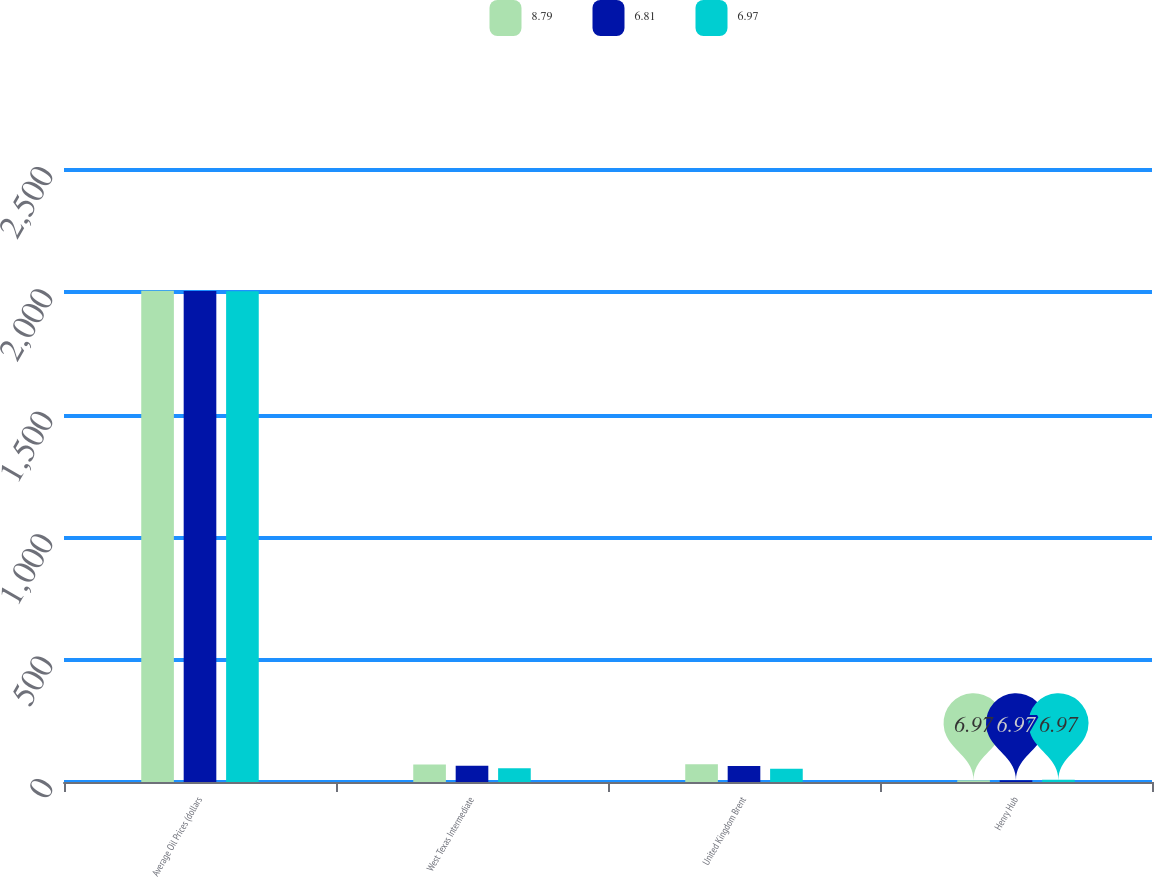Convert chart to OTSL. <chart><loc_0><loc_0><loc_500><loc_500><stacked_bar_chart><ecel><fcel>Average Oil Prices (dollars<fcel>West Texas Intermediate<fcel>United Kingdom Brent<fcel>Henry Hub<nl><fcel>8.79<fcel>2007<fcel>71.91<fcel>72.21<fcel>6.97<nl><fcel>6.81<fcel>2006<fcel>66.17<fcel>65.35<fcel>6.81<nl><fcel>6.97<fcel>2005<fcel>56.3<fcel>54.45<fcel>8.79<nl></chart> 